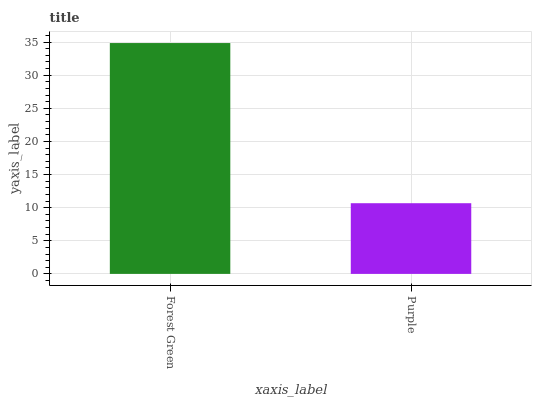Is Purple the minimum?
Answer yes or no. Yes. Is Forest Green the maximum?
Answer yes or no. Yes. Is Purple the maximum?
Answer yes or no. No. Is Forest Green greater than Purple?
Answer yes or no. Yes. Is Purple less than Forest Green?
Answer yes or no. Yes. Is Purple greater than Forest Green?
Answer yes or no. No. Is Forest Green less than Purple?
Answer yes or no. No. Is Forest Green the high median?
Answer yes or no. Yes. Is Purple the low median?
Answer yes or no. Yes. Is Purple the high median?
Answer yes or no. No. Is Forest Green the low median?
Answer yes or no. No. 